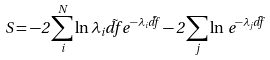<formula> <loc_0><loc_0><loc_500><loc_500>S = - 2 \sum _ { i } ^ { N } \ln \lambda _ { i } \vec { d f } e ^ { - \lambda _ { i } \vec { d f } } - 2 \sum _ { j } \ln \, e ^ { - \lambda _ { j } \vec { d f } }</formula> 